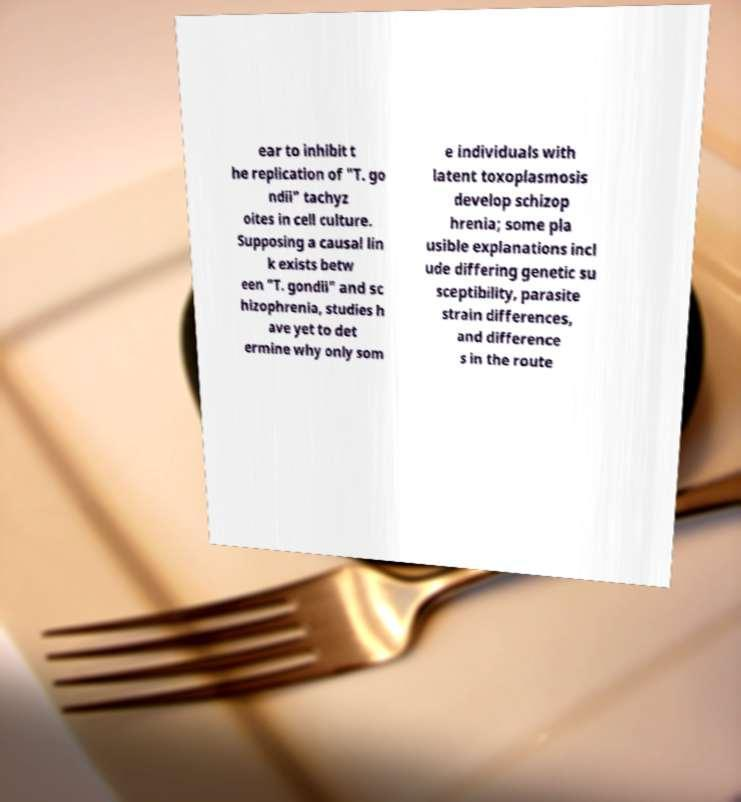Could you assist in decoding the text presented in this image and type it out clearly? ear to inhibit t he replication of "T. go ndii" tachyz oites in cell culture. Supposing a causal lin k exists betw een "T. gondii" and sc hizophrenia, studies h ave yet to det ermine why only som e individuals with latent toxoplasmosis develop schizop hrenia; some pla usible explanations incl ude differing genetic su sceptibility, parasite strain differences, and difference s in the route 